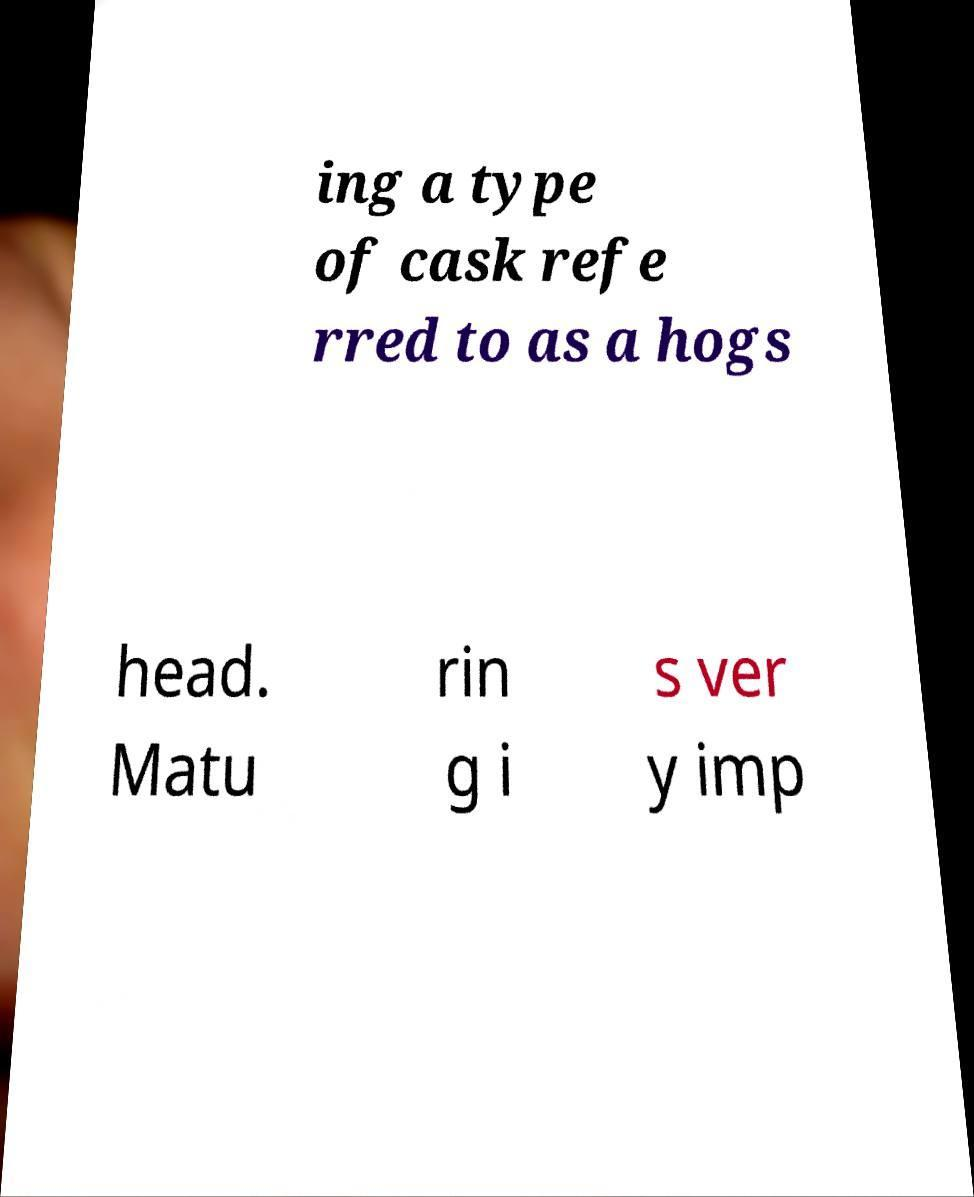Could you assist in decoding the text presented in this image and type it out clearly? ing a type of cask refe rred to as a hogs head. Matu rin g i s ver y imp 